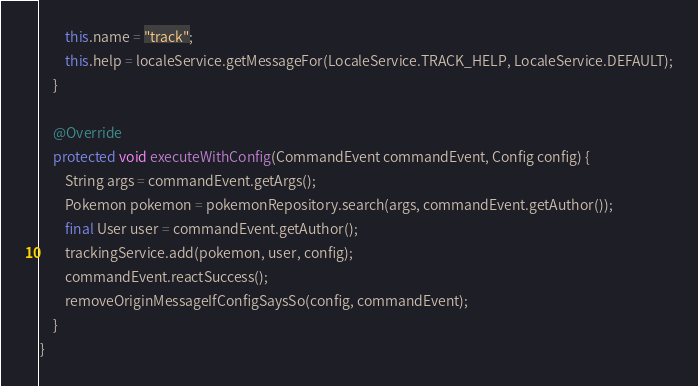<code> <loc_0><loc_0><loc_500><loc_500><_Java_>        this.name = "track";
        this.help = localeService.getMessageFor(LocaleService.TRACK_HELP, LocaleService.DEFAULT);
    }

    @Override
    protected void executeWithConfig(CommandEvent commandEvent, Config config) {
        String args = commandEvent.getArgs();
        Pokemon pokemon = pokemonRepository.search(args, commandEvent.getAuthor());
        final User user = commandEvent.getAuthor();
        trackingService.add(pokemon, user, config);
        commandEvent.reactSuccess();
        removeOriginMessageIfConfigSaysSo(config, commandEvent);
    }
}</code> 